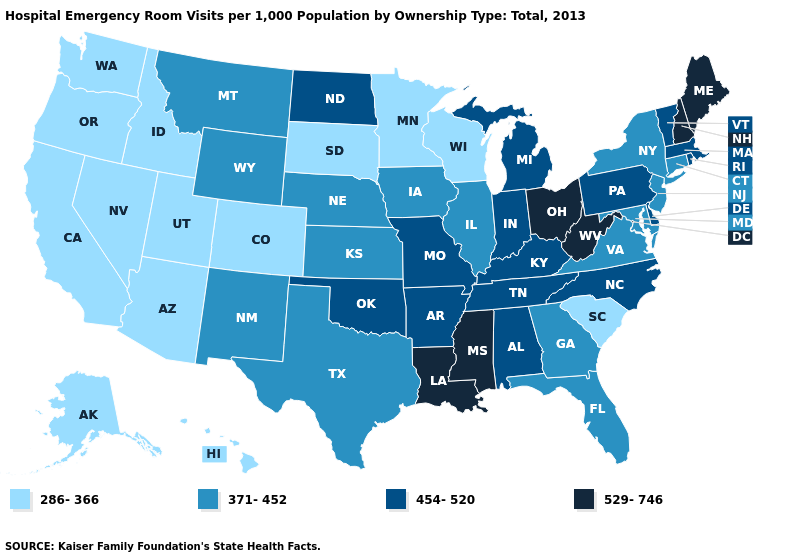What is the value of Minnesota?
Quick response, please. 286-366. Name the states that have a value in the range 529-746?
Keep it brief. Louisiana, Maine, Mississippi, New Hampshire, Ohio, West Virginia. What is the value of New York?
Give a very brief answer. 371-452. What is the highest value in the USA?
Concise answer only. 529-746. How many symbols are there in the legend?
Be succinct. 4. Does Louisiana have the highest value in the USA?
Short answer required. Yes. Does Connecticut have the lowest value in the Northeast?
Answer briefly. Yes. Name the states that have a value in the range 371-452?
Be succinct. Connecticut, Florida, Georgia, Illinois, Iowa, Kansas, Maryland, Montana, Nebraska, New Jersey, New Mexico, New York, Texas, Virginia, Wyoming. Name the states that have a value in the range 286-366?
Answer briefly. Alaska, Arizona, California, Colorado, Hawaii, Idaho, Minnesota, Nevada, Oregon, South Carolina, South Dakota, Utah, Washington, Wisconsin. Which states have the lowest value in the South?
Give a very brief answer. South Carolina. What is the value of Nebraska?
Be succinct. 371-452. Among the states that border Virginia , which have the lowest value?
Short answer required. Maryland. What is the value of Texas?
Write a very short answer. 371-452. 